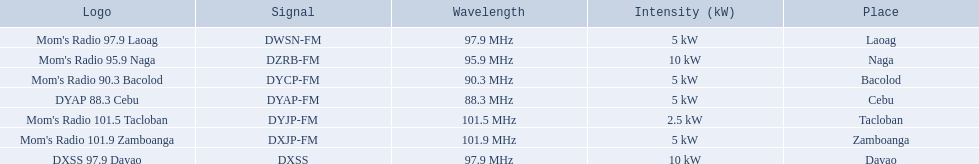What brandings have a power of 5 kw? Mom's Radio 97.9 Laoag, Mom's Radio 90.3 Bacolod, DYAP 88.3 Cebu, Mom's Radio 101.9 Zamboanga. Which of these has a call-sign beginning with dy? Mom's Radio 90.3 Bacolod, DYAP 88.3 Cebu. Which of those uses the lowest frequency? DYAP 88.3 Cebu. 